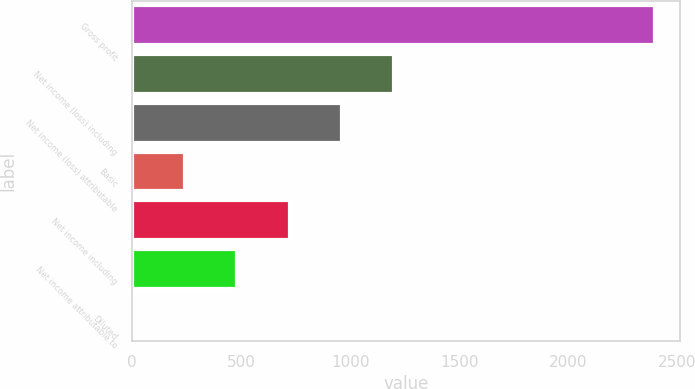Convert chart to OTSL. <chart><loc_0><loc_0><loc_500><loc_500><bar_chart><fcel>Gross profit<fcel>Net income (loss) including<fcel>Net income (loss) attributable<fcel>Basic<fcel>Net income including<fcel>Net income attributable to<fcel>Diluted<nl><fcel>2392<fcel>1196.22<fcel>957.06<fcel>239.58<fcel>717.9<fcel>478.74<fcel>0.42<nl></chart> 